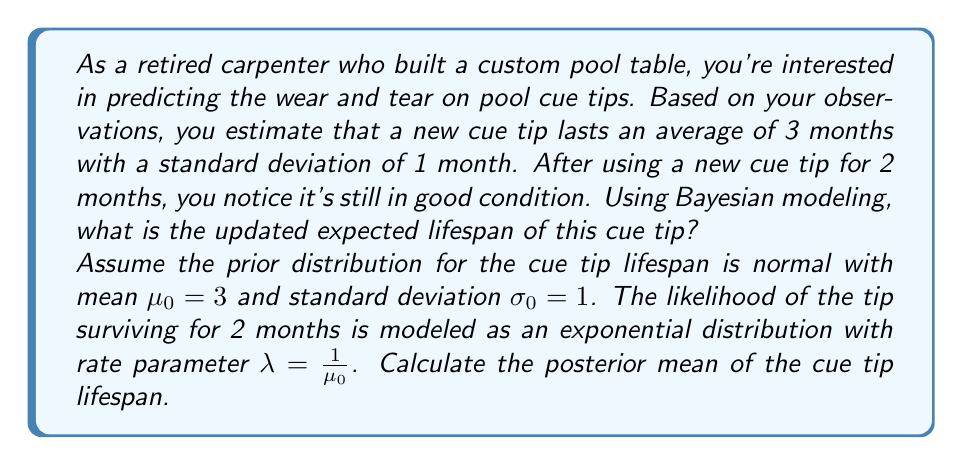Provide a solution to this math problem. To solve this problem using Bayesian modeling, we'll follow these steps:

1. Define the prior distribution:
   The prior is normal with $\mu_0 = 3$ and $\sigma_0 = 1$.
   
2. Define the likelihood function:
   The likelihood of the tip surviving for 2 months is modeled as an exponential distribution with rate parameter $\lambda = \frac{1}{\mu_0} = \frac{1}{3}$.
   
3. Calculate the posterior distribution:
   For conjugate priors, the posterior mean is a weighted average of the prior mean and the observed data, where the weights are determined by the relative precisions of the prior and the likelihood.

4. Calculate the posterior mean:
   The formula for the posterior mean in this case is:

   $$\mu_1 = \frac{\frac{\mu_0}{\sigma_0^2} + \frac{x}{\sigma^2}}{\frac{1}{\sigma_0^2} + \frac{1}{\sigma^2}}$$

   Where:
   - $\mu_0 = 3$ (prior mean)
   - $\sigma_0 = 1$ (prior standard deviation)
   - $x = 2$ (observed survival time)
   - $\sigma^2 = \mu_0^2 = 3^2 = 9$ (variance of the exponential distribution)

5. Plug in the values:

   $$\mu_1 = \frac{\frac{3}{1^2} + \frac{2}{9}}{\frac{1}{1^2} + \frac{1}{9}}$$

6. Simplify:

   $$\mu_1 = \frac{3 + \frac{2}{9}}{\frac{10}{9}} = \frac{27 + 2}{10} = \frac{29}{10} = 2.9$$

Therefore, the updated expected lifespan of the cue tip is 2.9 months.
Answer: 2.9 months 